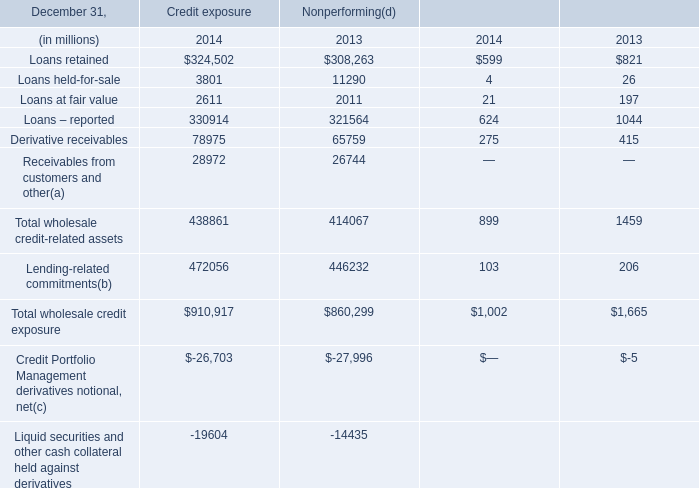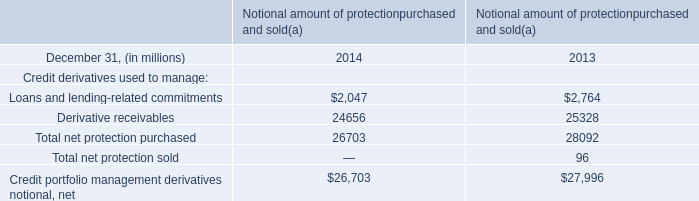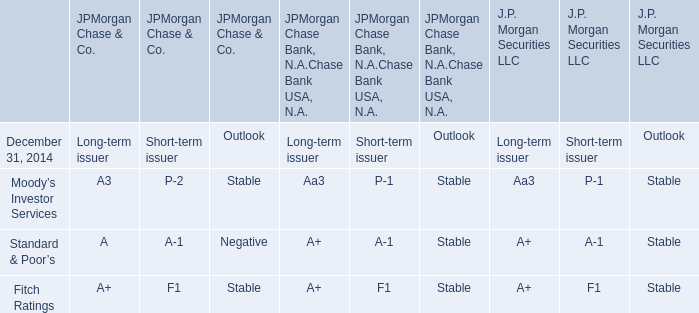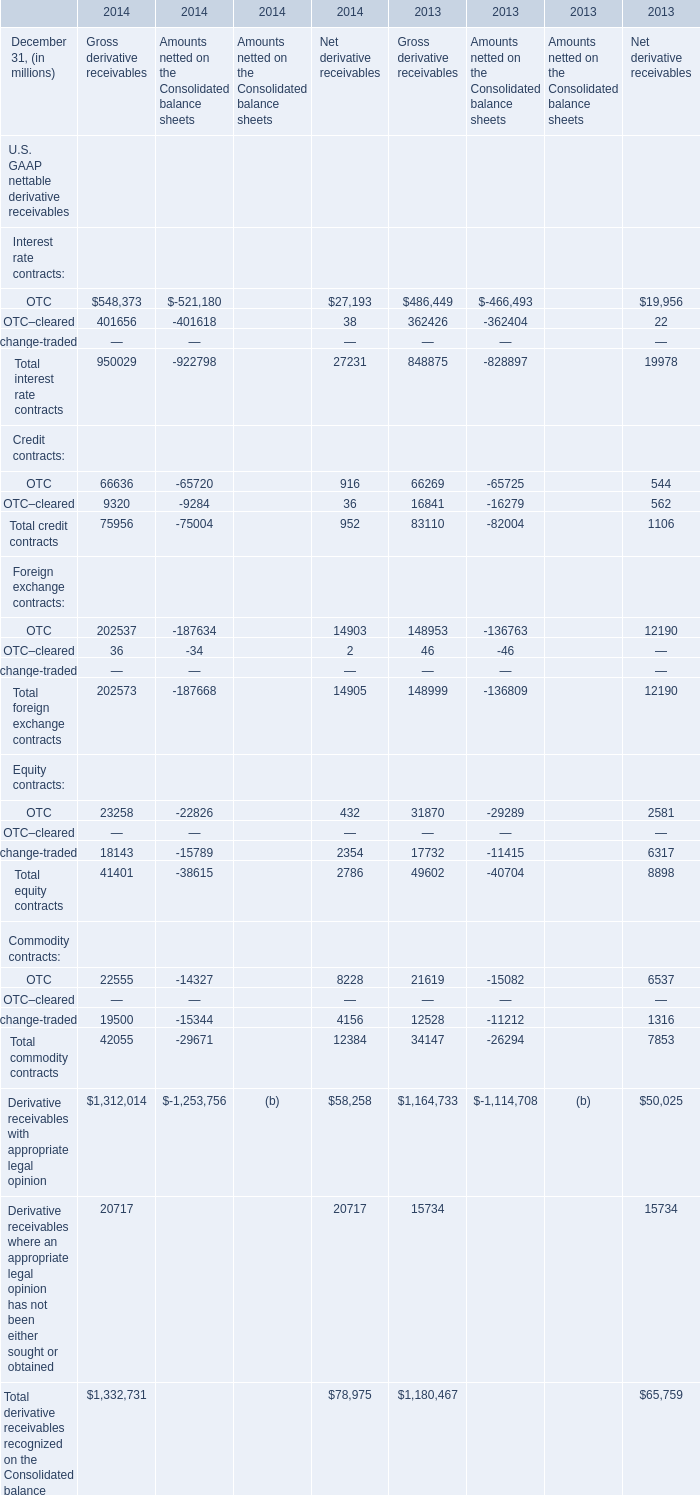What's the sum of OTC–cleared of 2013 Gross derivative receivables, and Loans at fair value of Credit exposure 2014 ? 
Computations: (362426.0 + 2611.0)
Answer: 365037.0. 